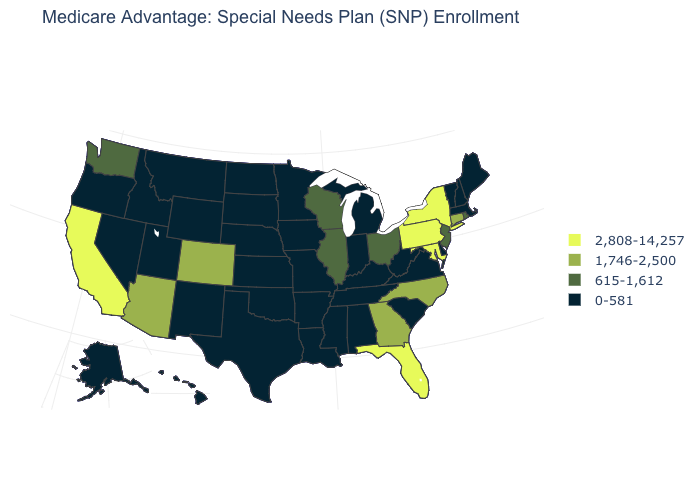Name the states that have a value in the range 615-1,612?
Give a very brief answer. Illinois, New Jersey, Ohio, Rhode Island, Washington, Wisconsin. What is the value of Ohio?
Keep it brief. 615-1,612. Among the states that border Texas , which have the lowest value?
Keep it brief. Arkansas, Louisiana, New Mexico, Oklahoma. Does Tennessee have the highest value in the USA?
Concise answer only. No. Among the states that border Wyoming , does Nebraska have the lowest value?
Give a very brief answer. Yes. What is the value of Vermont?
Concise answer only. 0-581. Does Illinois have a lower value than New York?
Keep it brief. Yes. Is the legend a continuous bar?
Answer briefly. No. What is the lowest value in the Northeast?
Write a very short answer. 0-581. Does North Dakota have the lowest value in the USA?
Quick response, please. Yes. Does New Jersey have a lower value than Colorado?
Answer briefly. Yes. What is the lowest value in the USA?
Give a very brief answer. 0-581. Which states have the lowest value in the West?
Write a very short answer. Alaska, Hawaii, Idaho, Montana, New Mexico, Nevada, Oregon, Utah, Wyoming. Name the states that have a value in the range 1,746-2,500?
Concise answer only. Arizona, Colorado, Connecticut, Georgia, North Carolina. Which states have the lowest value in the Northeast?
Write a very short answer. Massachusetts, Maine, New Hampshire, Vermont. 